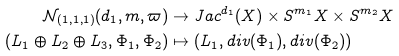Convert formula to latex. <formula><loc_0><loc_0><loc_500><loc_500>\mathcal { N } _ { ( 1 , 1 , 1 ) } ( d _ { 1 } , m , \varpi ) & \to J a c ^ { d _ { 1 } } ( X ) \times S ^ { { m } _ { 1 } } X \times S ^ { { m } _ { 2 } } X \\ ( L _ { 1 } \oplus L _ { 2 } \oplus L _ { 3 } , \Phi _ { 1 } , \Phi _ { 2 } ) & \mapsto ( L _ { 1 } , d i v ( \Phi _ { 1 } ) , d i v ( \Phi _ { 2 } ) )</formula> 